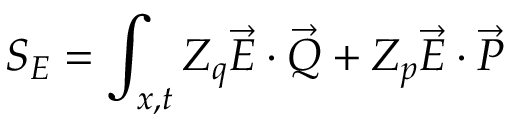<formula> <loc_0><loc_0><loc_500><loc_500>S _ { E } = \int _ { x , t } Z _ { q } \vec { E } \cdot \vec { Q } + Z _ { p } \vec { E } \cdot \vec { P }</formula> 